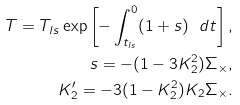Convert formula to latex. <formula><loc_0><loc_0><loc_500><loc_500>T = T _ { l s } \exp \left [ - \int _ { t _ { l s } } ^ { 0 } ( 1 + s ) \ d t \right ] , \\ s = - ( 1 - 3 K _ { 2 } ^ { 2 } ) \Sigma _ { \times } , \\ K _ { 2 } ^ { \prime } = - 3 ( 1 - K _ { 2 } ^ { 2 } ) K _ { 2 } \Sigma _ { \times } .</formula> 